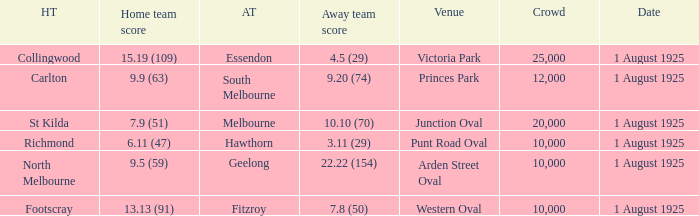At the match where the away team scored 4.5 (29), what was the crowd size? 1.0. 